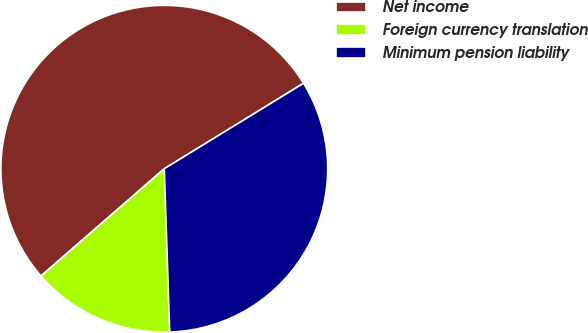<chart> <loc_0><loc_0><loc_500><loc_500><pie_chart><fcel>Net income<fcel>Foreign currency translation<fcel>Minimum pension liability<nl><fcel>52.63%<fcel>14.13%<fcel>33.23%<nl></chart> 